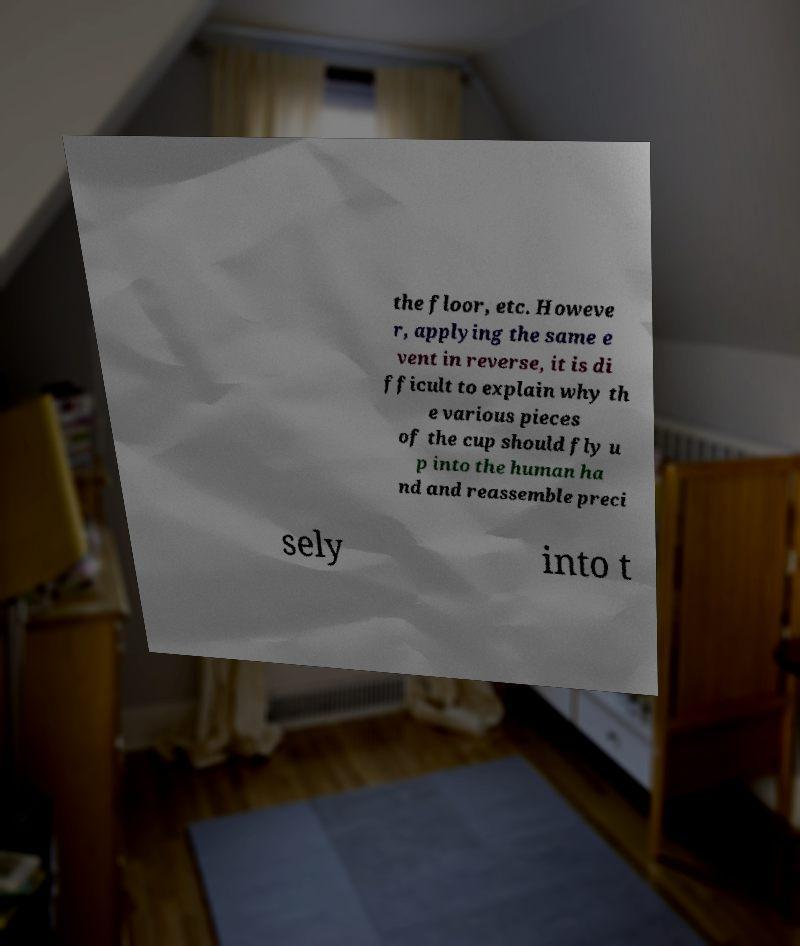There's text embedded in this image that I need extracted. Can you transcribe it verbatim? the floor, etc. Howeve r, applying the same e vent in reverse, it is di fficult to explain why th e various pieces of the cup should fly u p into the human ha nd and reassemble preci sely into t 